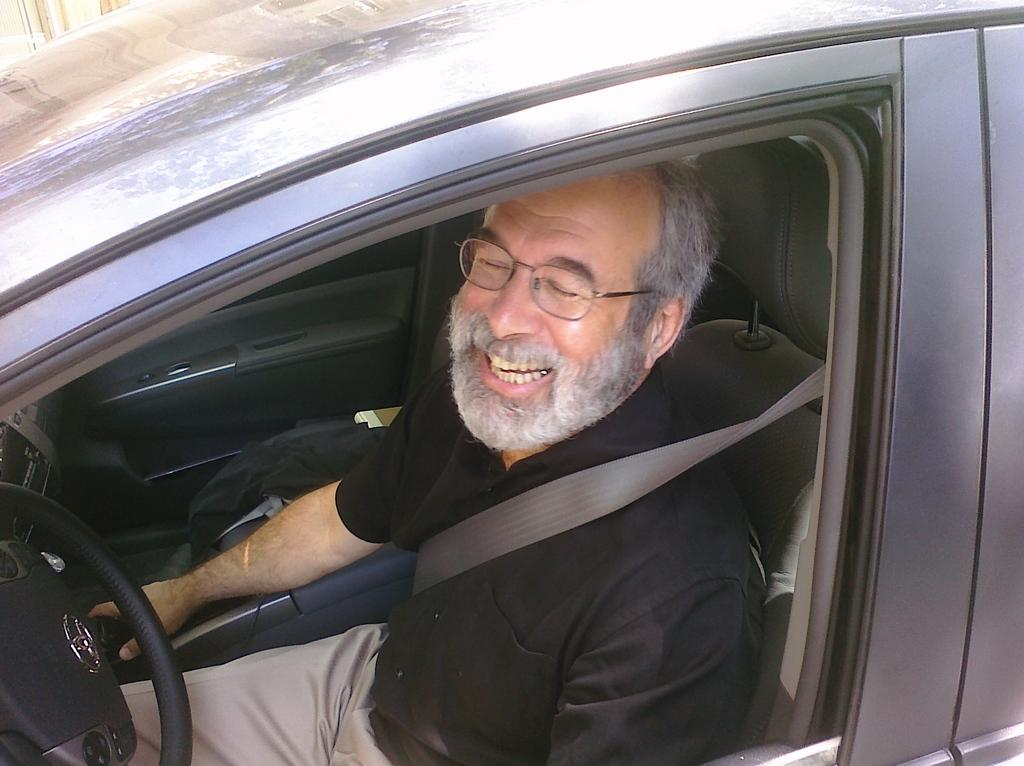Who is the main subject in the image? There is an old man in the image. What is the old man doing in the image? The old man is sitting in a car. What is in front of the old man in the car? There is a steering wheel in front of the old man. What type of thrill can be experienced by the old man while sitting in the car? The image does not provide any information about the old man experiencing a thrill while sitting in the car. What credit card is the old man using to pay for the car rental? The image does not provide any information about the old man using a credit card or renting a car. 